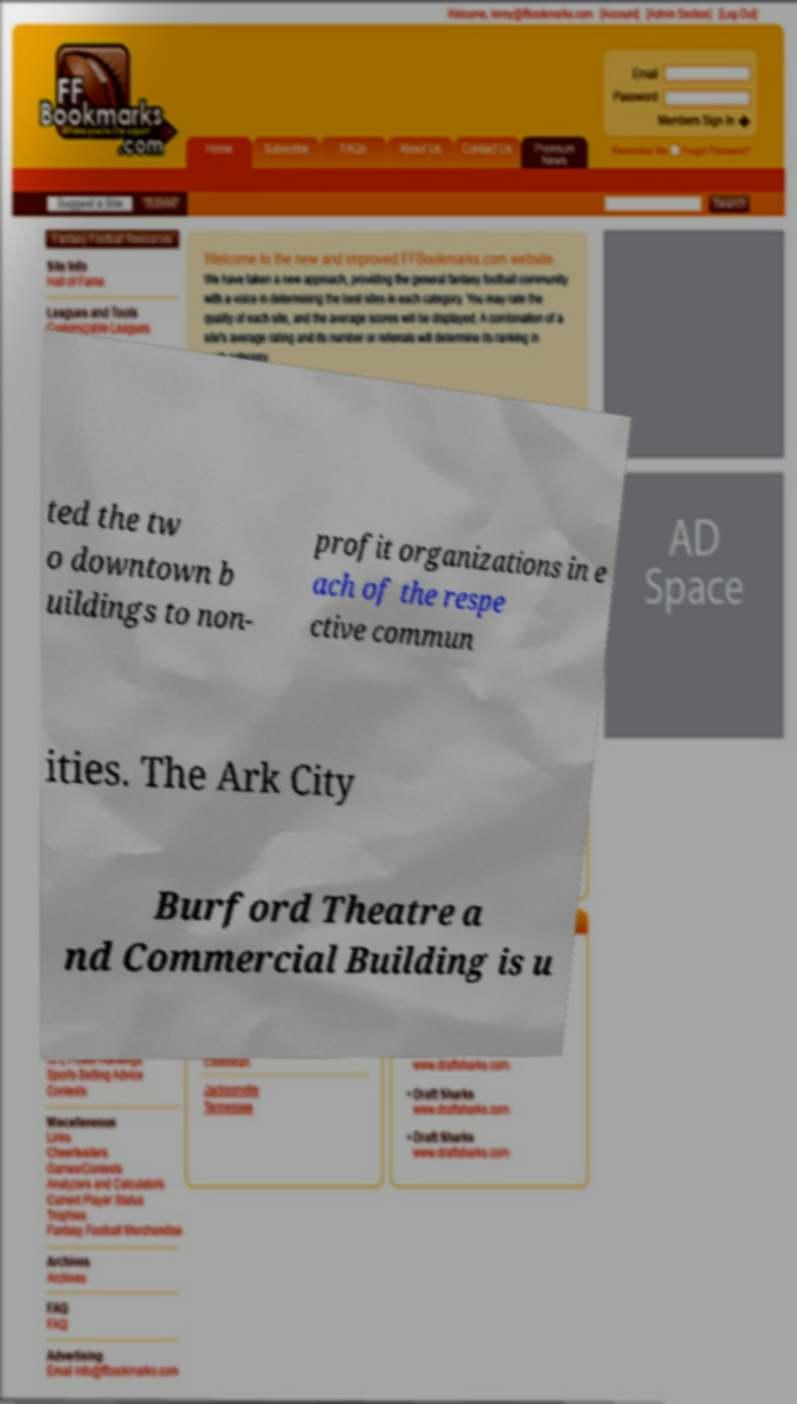Could you extract and type out the text from this image? ted the tw o downtown b uildings to non- profit organizations in e ach of the respe ctive commun ities. The Ark City Burford Theatre a nd Commercial Building is u 